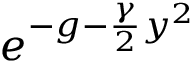Convert formula to latex. <formula><loc_0><loc_0><loc_500><loc_500>e ^ { - g - { \frac { \gamma } { 2 } } y ^ { 2 } }</formula> 